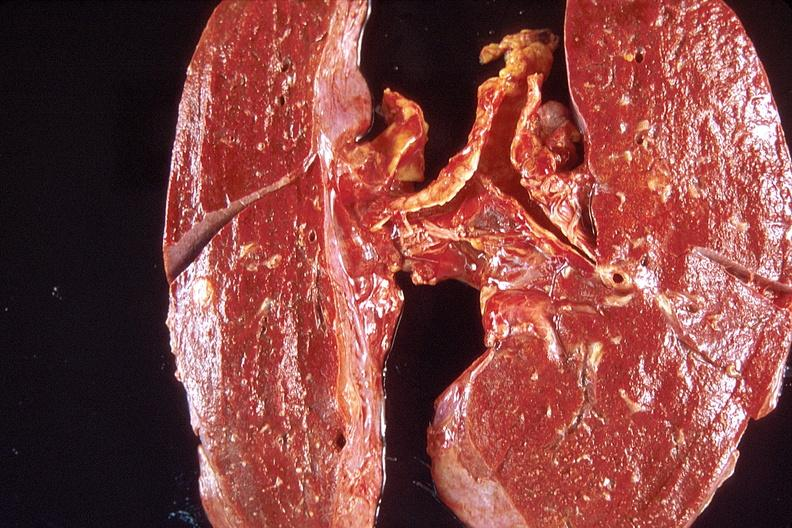does this image show lung, diffuse alveolar damage?
Answer the question using a single word or phrase. Yes 